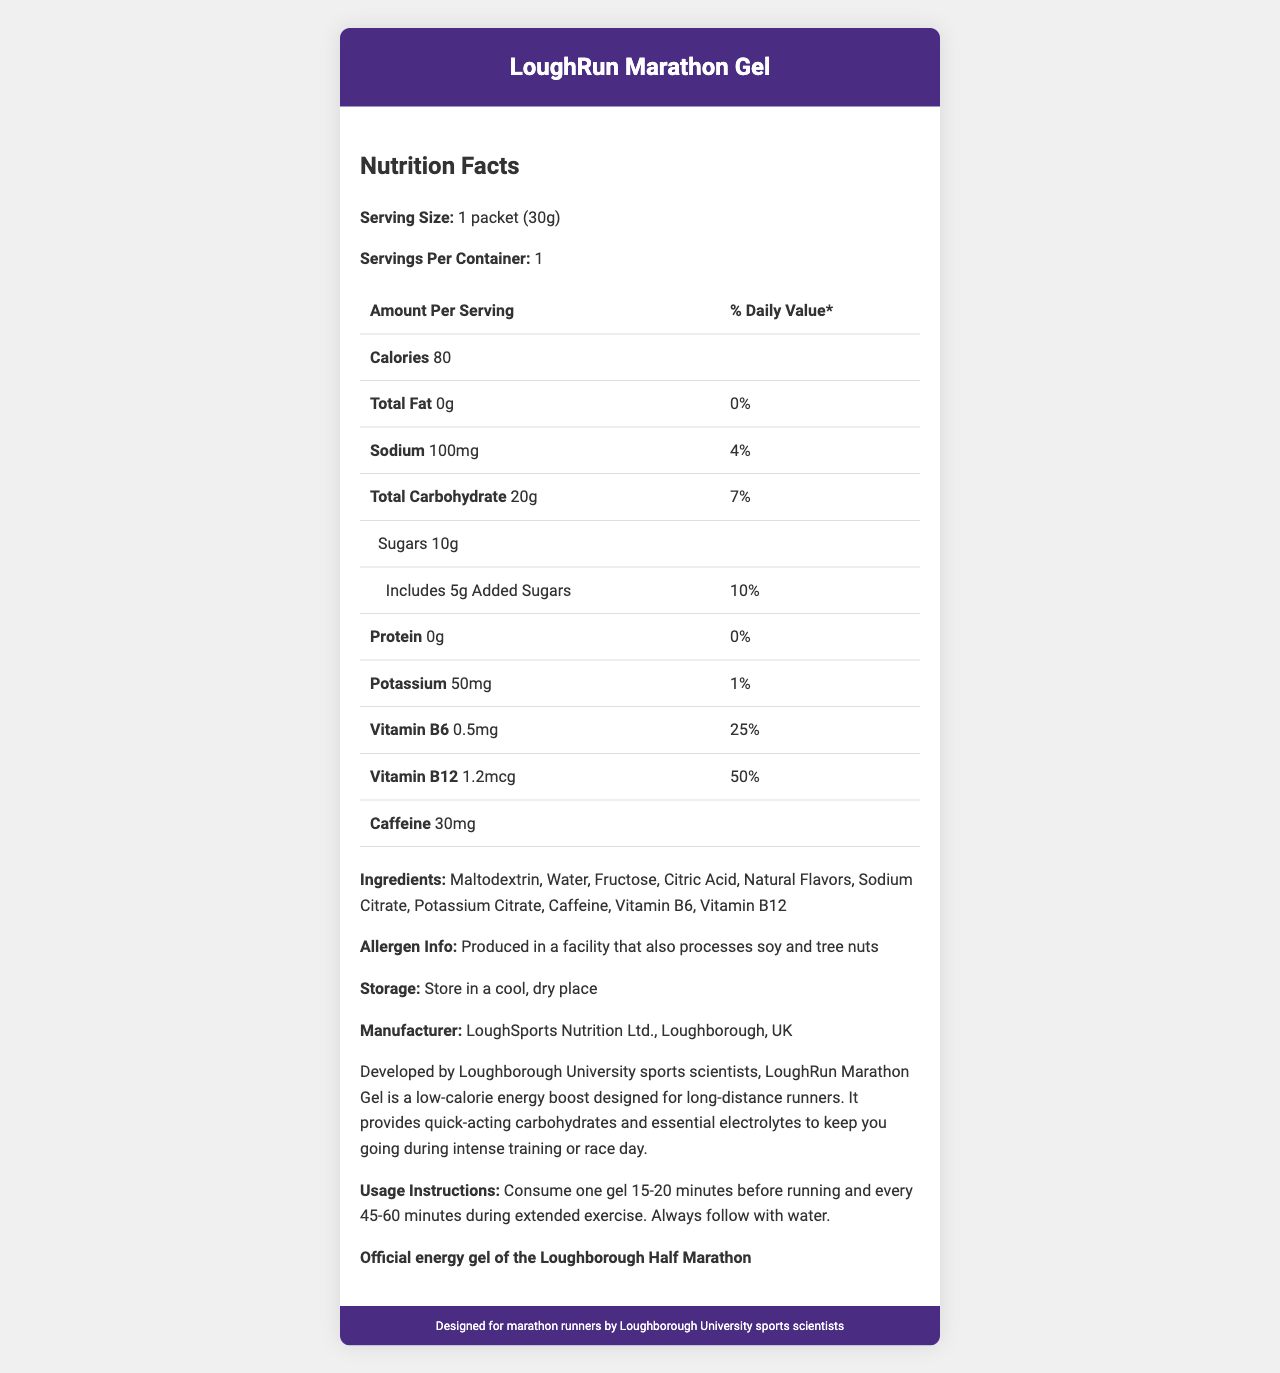what is the serving size of the LoughRun Marathon Gel? The document states the serving size as "1 packet (30g)" under the Nutrition Facts section.
Answer: 1 packet (30g) how many milligrams of caffeine are in one serving? The document lists "Caffeine 30mg" in the Nutrition Facts table.
Answer: 30mg how many grams of total carbohydrates are provided per serving? The Nutrition Facts table shows that the total carbohydrate amount per serving is "20g."
Answer: 20g what is the percent daily value of sodium in one packet? The document indicates that the sodium content has a percent daily value of "4%" per serving.
Answer: 4% how much vitamin B12 does the LoughRun Marathon Gel contain? The Nutrition Facts section states that there is "Vitamin B12: 1.2mcg" in one serving.
Answer: 1.2mcg what are the first three ingredients listed? In the Ingredients section, the first three listed ingredients are "Maltodextrin, Water, Fructose."
Answer: Maltodextrin, Water, Fructose which electrolyte is included in the gel, and what is its amount? The Nutrition Facts table shows that the gel contains "Sodium 100mg."
Answer: Sodium, 100mg what is the manufacturer's name and location? The document states the manufacturer as "LoughSports Nutrition Ltd., Loughborough, UK."
Answer: LoughSports Nutrition Ltd., Loughborough, UK what is the total number of calories in one packet? According to the Nutrition Facts, there are "Calories 80" per serving.
Answer: 80 how many grams of sugars are added to the product? The Nutrition Facts section details that the added sugars amount to "5g."
Answer: 5g what is the main idea of the document? The document describes the nutritional content, ingredients, allergens, and manufacturer details of the LoughRun Marathon Gel, as well as how to use and store it.
Answer: The document provides detailed Nutrition Facts for the LoughRun Marathon Gel, a low-calorie energy gel designed for marathon runners, including its ingredients, nutritional content, storage information, and usage instructions. how should the gel be stored? The document advises storing the product in "a cool, dry place."
Answer: Store in a cool, dry place choose the correct serving instructions: (i) Consume two gels before running and every hour during exercise. (ii) Consume one gel 15-20 minutes before running and every 45-60 minutes during extended exercise. (iii) Avoid consuming gels during exercise. The document states, "Consume one gel 15-20 minutes before running and every 45-60 minutes during extended exercise. Always follow with water."
Answer: ii which vitamin has a higher percent daily value per serving? A. Vitamin B6 B. Vitamin B12 C. Both B6 and B12 have the same % daily value The Nutrition Facts section shows that Vitamin B6 has a percent daily value of "25%" while Vitamin B12 has "50%."
Answer: B does the gel contain any protein? The document indicates "Protein 0g" with a percent daily value of "0%."
Answer: No was the gel developed specifically for sprinters? The document states that the LoughRun Marathon Gel was developed for long-distance runners, not specifically for sprinters.
Answer: No where can one find the presence of tree nuts in the allergen information? The document mentions that it is produced in a facility that also processes soy and tree nuts, but it does not specify the presence of tree nuts in the product itself.
Answer: Cannot be determined 